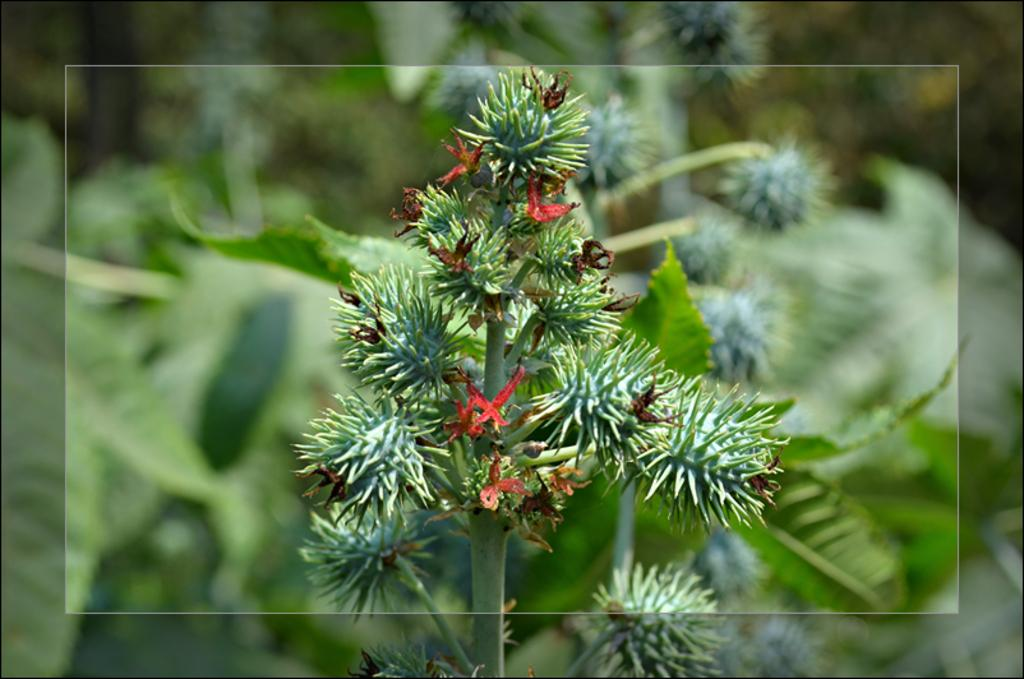What type of flowers can be seen on the plants in the image? There are white flowers on the plants in the image. What else can be seen on the plants besides the flowers? There are leaves visible in the image. What type of bridge can be seen in the image? There is no bridge present in the image; it features white flowers on plants with leaves. 